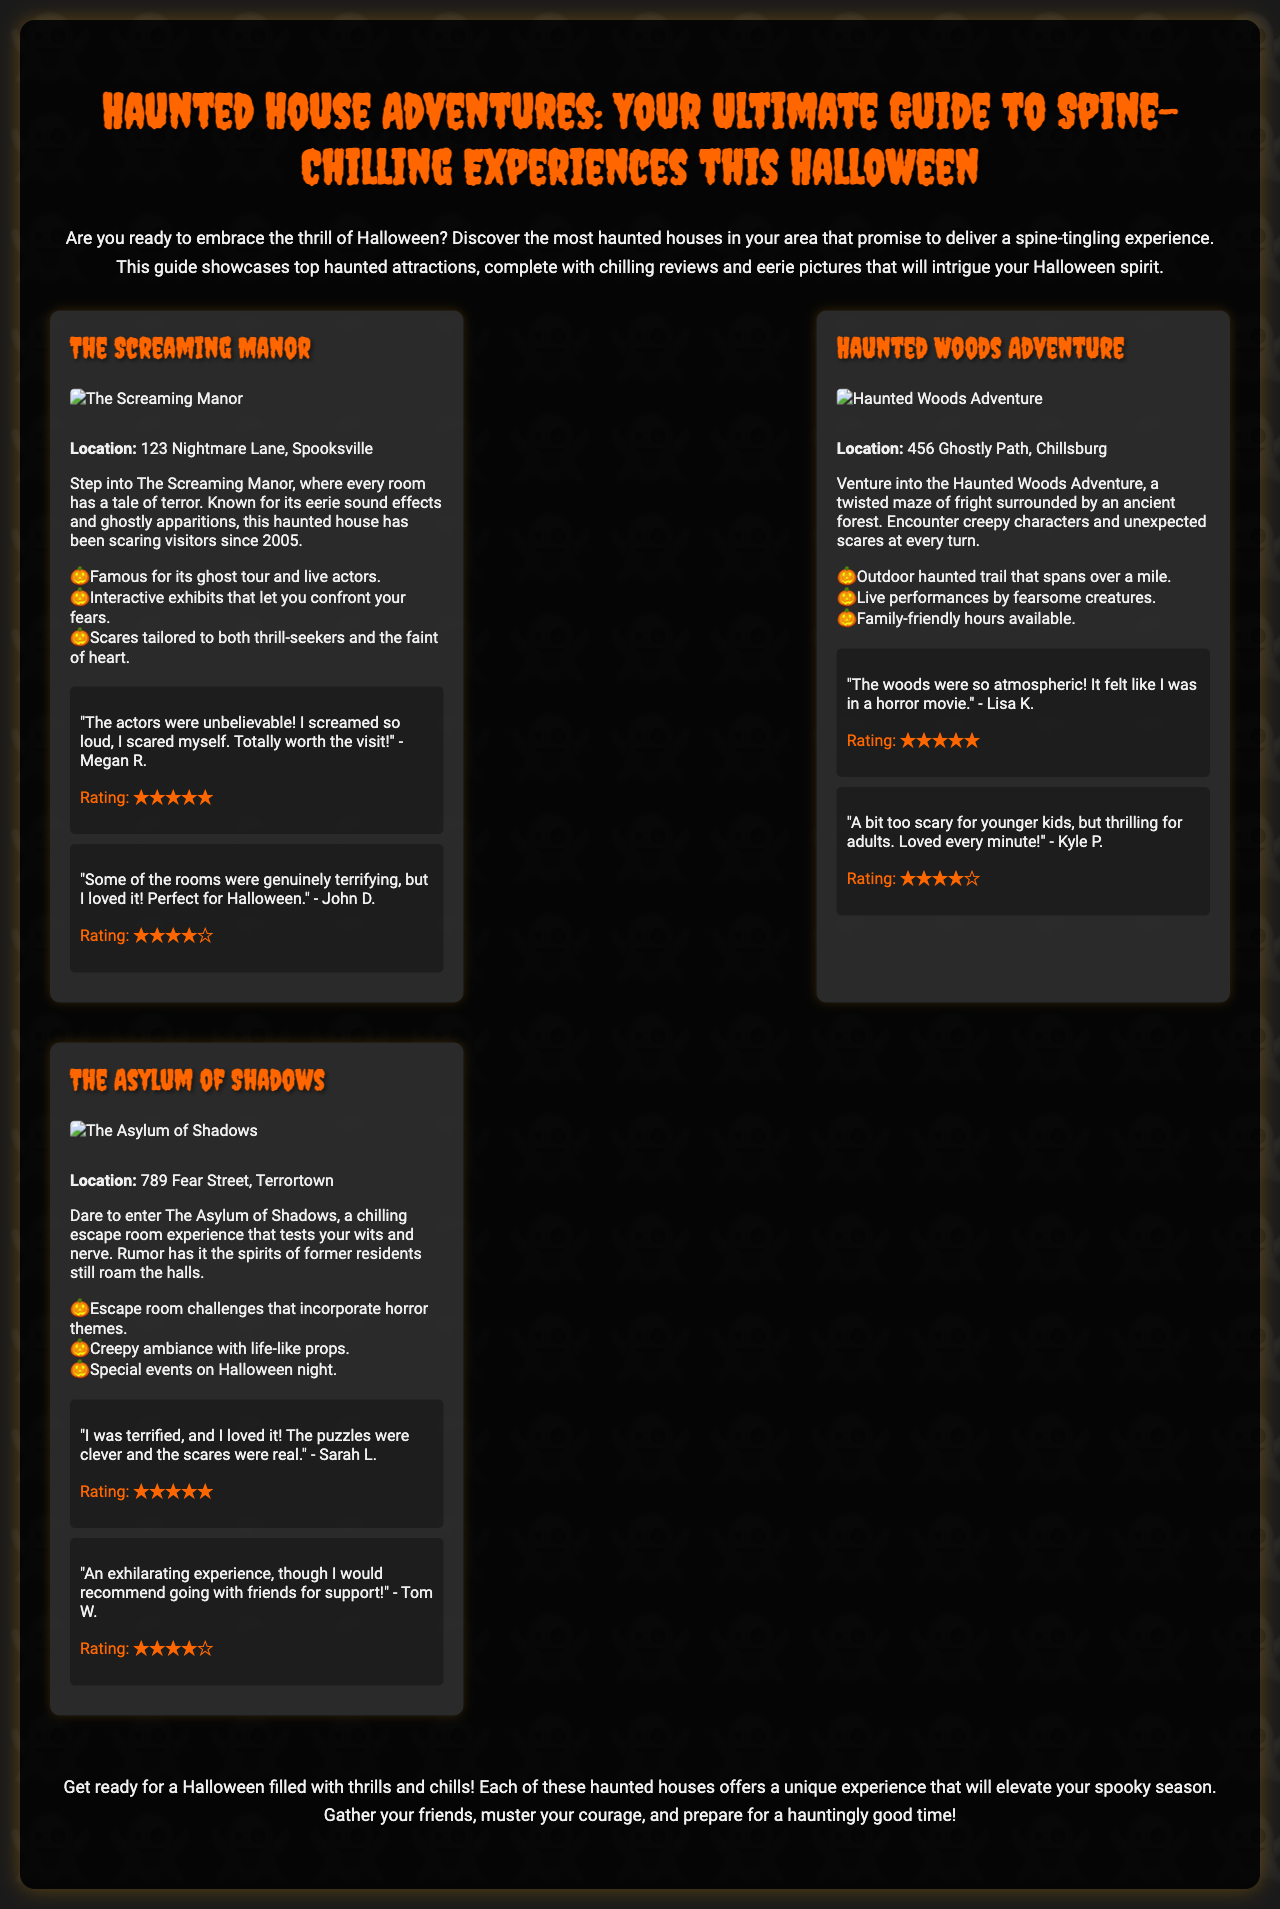What is the name of the first haunted house? The first haunted house listed in the document is "The Screaming Manor."
Answer: The Screaming Manor How many haunted houses are featured in the brochure? There are three haunted houses presented in the document.
Answer: Three What is the location of Haunted Woods Adventure? The Haunted Woods Adventure is located at "456 Ghostly Path, Chillsburg."
Answer: 456 Ghostly Path, Chillsburg Which haunted house has interactive exhibits? The haunted house known for its interactive exhibits is "The Screaming Manor."
Answer: The Screaming Manor What rating did Megan R. give to The Screaming Manor? Megan R. rated The Screaming Manor with five stars.
Answer: ★★★★★ Which haunted house is described as an escape room experience? "The Asylum of Shadows" is described as an escape room experience.
Answer: The Asylum of Shadows Is there a family-friendly option available at the Haunted Woods Adventure? Yes, family-friendly hours are available at the Haunted Woods Adventure.
Answer: Yes What type of ambiance does The Asylum of Shadows offer? The Asylum of Shadows offers a creepy ambiance with life-like props.
Answer: Creepy ambiance with life-like props What is the main theme of the haunted houses in this brochure? The main theme of the haunted houses is Halloween thrill and chills.
Answer: Halloween thrill 